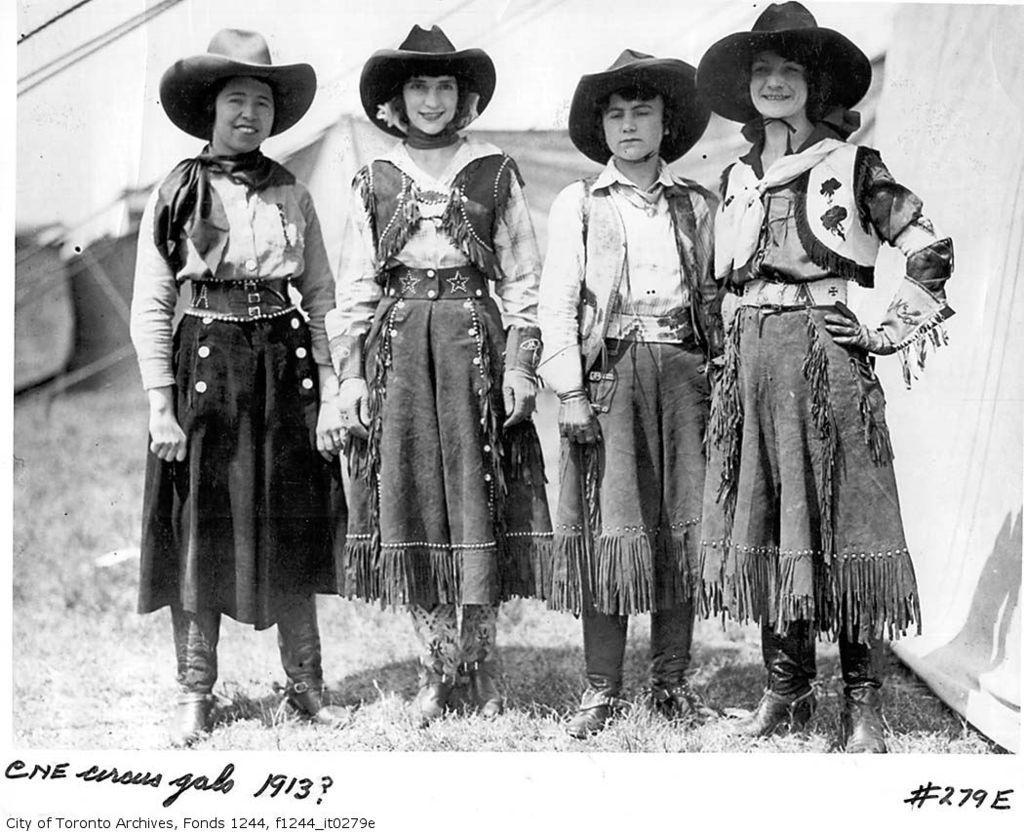Please provide a concise description of this image. This is a black and white image. In the center we can see the group of people wearing hats and dresses and standing o the ground. In the background we can see the grass, tents and some other objects. At the bottom there is a text on the image. 